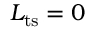<formula> <loc_0><loc_0><loc_500><loc_500>L _ { t s } = 0</formula> 